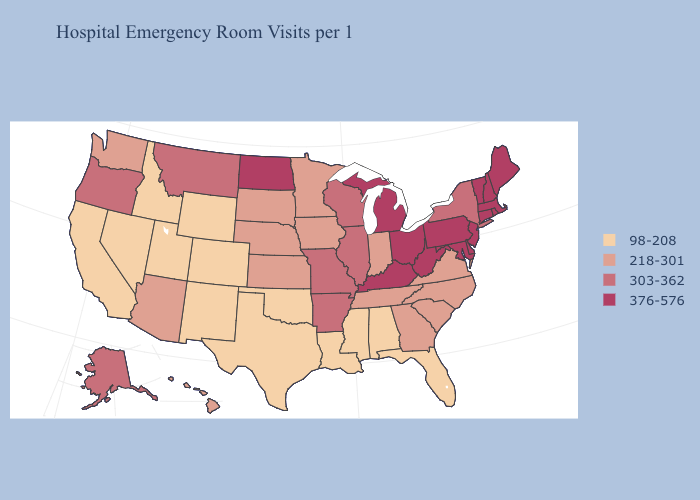How many symbols are there in the legend?
Answer briefly. 4. What is the value of Arizona?
Be succinct. 218-301. Does Indiana have a higher value than Pennsylvania?
Keep it brief. No. How many symbols are there in the legend?
Short answer required. 4. Name the states that have a value in the range 98-208?
Concise answer only. Alabama, California, Colorado, Florida, Idaho, Louisiana, Mississippi, Nevada, New Mexico, Oklahoma, Texas, Utah, Wyoming. Among the states that border Nebraska , which have the lowest value?
Keep it brief. Colorado, Wyoming. Name the states that have a value in the range 218-301?
Give a very brief answer. Arizona, Georgia, Hawaii, Indiana, Iowa, Kansas, Minnesota, Nebraska, North Carolina, South Carolina, South Dakota, Tennessee, Virginia, Washington. What is the value of North Dakota?
Keep it brief. 376-576. What is the value of Vermont?
Short answer required. 376-576. What is the value of Kansas?
Concise answer only. 218-301. Which states have the highest value in the USA?
Answer briefly. Connecticut, Delaware, Kentucky, Maine, Maryland, Massachusetts, Michigan, New Hampshire, New Jersey, North Dakota, Ohio, Pennsylvania, Rhode Island, Vermont, West Virginia. Does Arizona have the highest value in the USA?
Keep it brief. No. Among the states that border Mississippi , which have the lowest value?
Keep it brief. Alabama, Louisiana. Name the states that have a value in the range 218-301?
Concise answer only. Arizona, Georgia, Hawaii, Indiana, Iowa, Kansas, Minnesota, Nebraska, North Carolina, South Carolina, South Dakota, Tennessee, Virginia, Washington. 